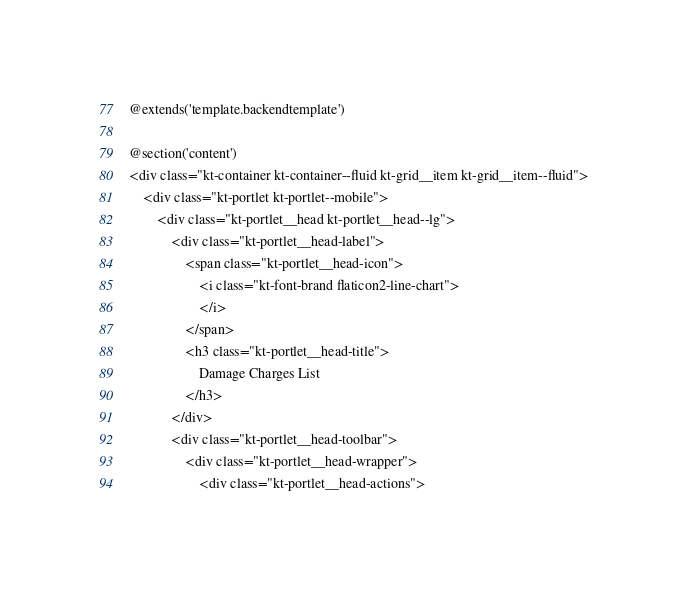Convert code to text. <code><loc_0><loc_0><loc_500><loc_500><_PHP_>@extends('template.backendtemplate')

@section('content')
<div class="kt-container kt-container--fluid kt-grid__item kt-grid__item--fluid">
    <div class="kt-portlet kt-portlet--mobile">
        <div class="kt-portlet__head kt-portlet__head--lg">
            <div class="kt-portlet__head-label">
                <span class="kt-portlet__head-icon">
                    <i class="kt-font-brand flaticon2-line-chart">
                    </i>
                </span>
                <h3 class="kt-portlet__head-title">
                    Damage Charges List
                </h3>
            </div>
            <div class="kt-portlet__head-toolbar">
                <div class="kt-portlet__head-wrapper">
                    <div class="kt-portlet__head-actions"></code> 